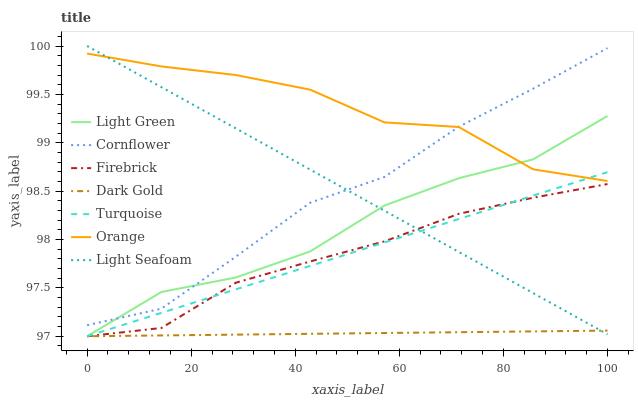Does Dark Gold have the minimum area under the curve?
Answer yes or no. Yes. Does Orange have the maximum area under the curve?
Answer yes or no. Yes. Does Turquoise have the minimum area under the curve?
Answer yes or no. No. Does Turquoise have the maximum area under the curve?
Answer yes or no. No. Is Turquoise the smoothest?
Answer yes or no. Yes. Is Orange the roughest?
Answer yes or no. Yes. Is Dark Gold the smoothest?
Answer yes or no. No. Is Dark Gold the roughest?
Answer yes or no. No. Does Orange have the lowest value?
Answer yes or no. No. Does Light Seafoam have the highest value?
Answer yes or no. Yes. Does Turquoise have the highest value?
Answer yes or no. No. Is Dark Gold less than Cornflower?
Answer yes or no. Yes. Is Orange greater than Firebrick?
Answer yes or no. Yes. Does Dark Gold intersect Cornflower?
Answer yes or no. No. 